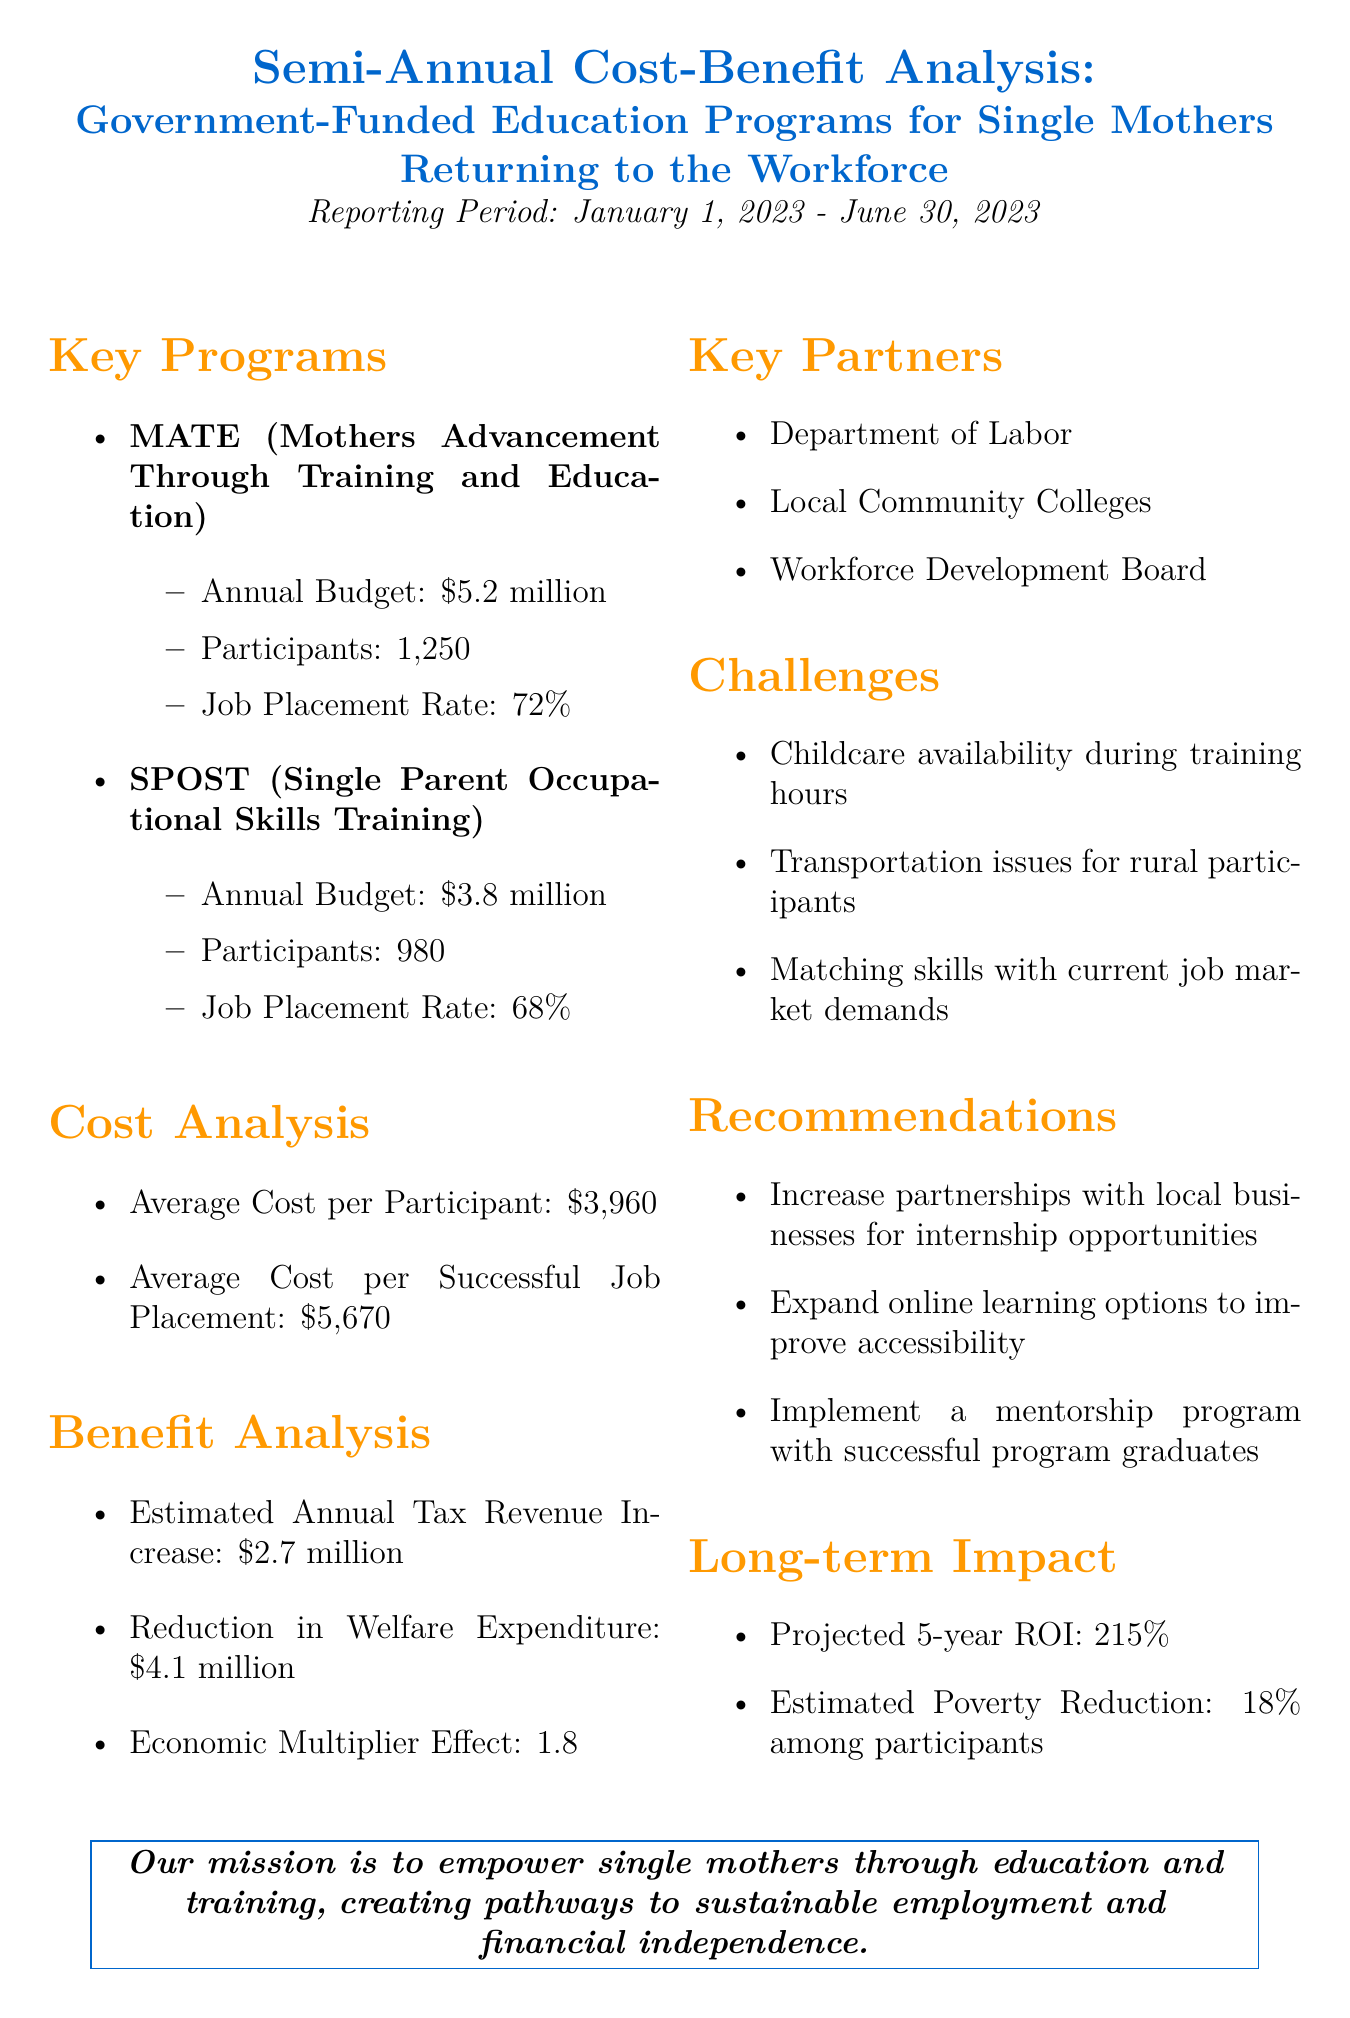What is the total annual budget for MATE and SPOST? The total annual budget is the sum of MATE's budget ($5.2 million) and SPOST's budget ($3.8 million), which equals $9 million.
Answer: $9 million What is the job placement rate for MATE? The job placement rate for MATE is explicitly stated in the document.
Answer: 72% What are the estimated annual tax revenue increase and reduction in welfare expenditure combined? Combining the estimated annual tax revenue increase ($2.7 million) and reduction in welfare expenditure ($4.1 million) gives a total of $6.8 million.
Answer: $6.8 million What are the projected 5-year ROI percentages for the education programs? The projected 5-year ROI is mentioned in the long-term impact section of the report.
Answer: 215% What challenge is mentioned regarding childcare? The document specifically points out issues related to childcare availability during training hours.
Answer: Childcare availability during training hours What is the average cost per successful job placement? The average cost per successful job placement is directly stated in the cost analysis section of the report.
Answer: $5,670 What recommendations are made for improving accessibility? The report recommends expanding online learning options to enhance program accessibility.
Answer: Expand online learning options How many participants are involved in the SPOST program? The number of participants for the SPOST program is specified in the key programs section of the document.
Answer: 980 What is the economic multiplier effect mentioned in the benefit analysis? The economic multiplier effect is a specific value mentioned in the benefit analysis section.
Answer: 1.8 